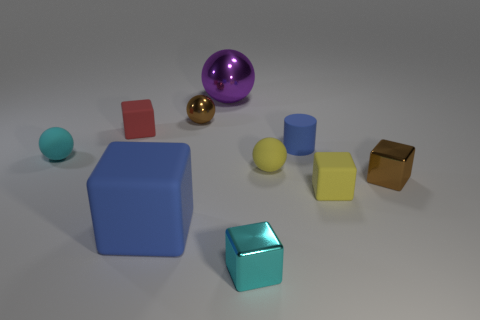Subtract all brown cubes. How many cubes are left? 4 Subtract all green cylinders. Subtract all yellow spheres. How many cylinders are left? 1 Subtract all cylinders. How many objects are left? 9 Add 9 tiny brown metallic balls. How many tiny brown metallic balls are left? 10 Add 5 small purple rubber things. How many small purple rubber things exist? 5 Subtract 0 brown cylinders. How many objects are left? 10 Subtract all green metallic blocks. Subtract all large blue cubes. How many objects are left? 9 